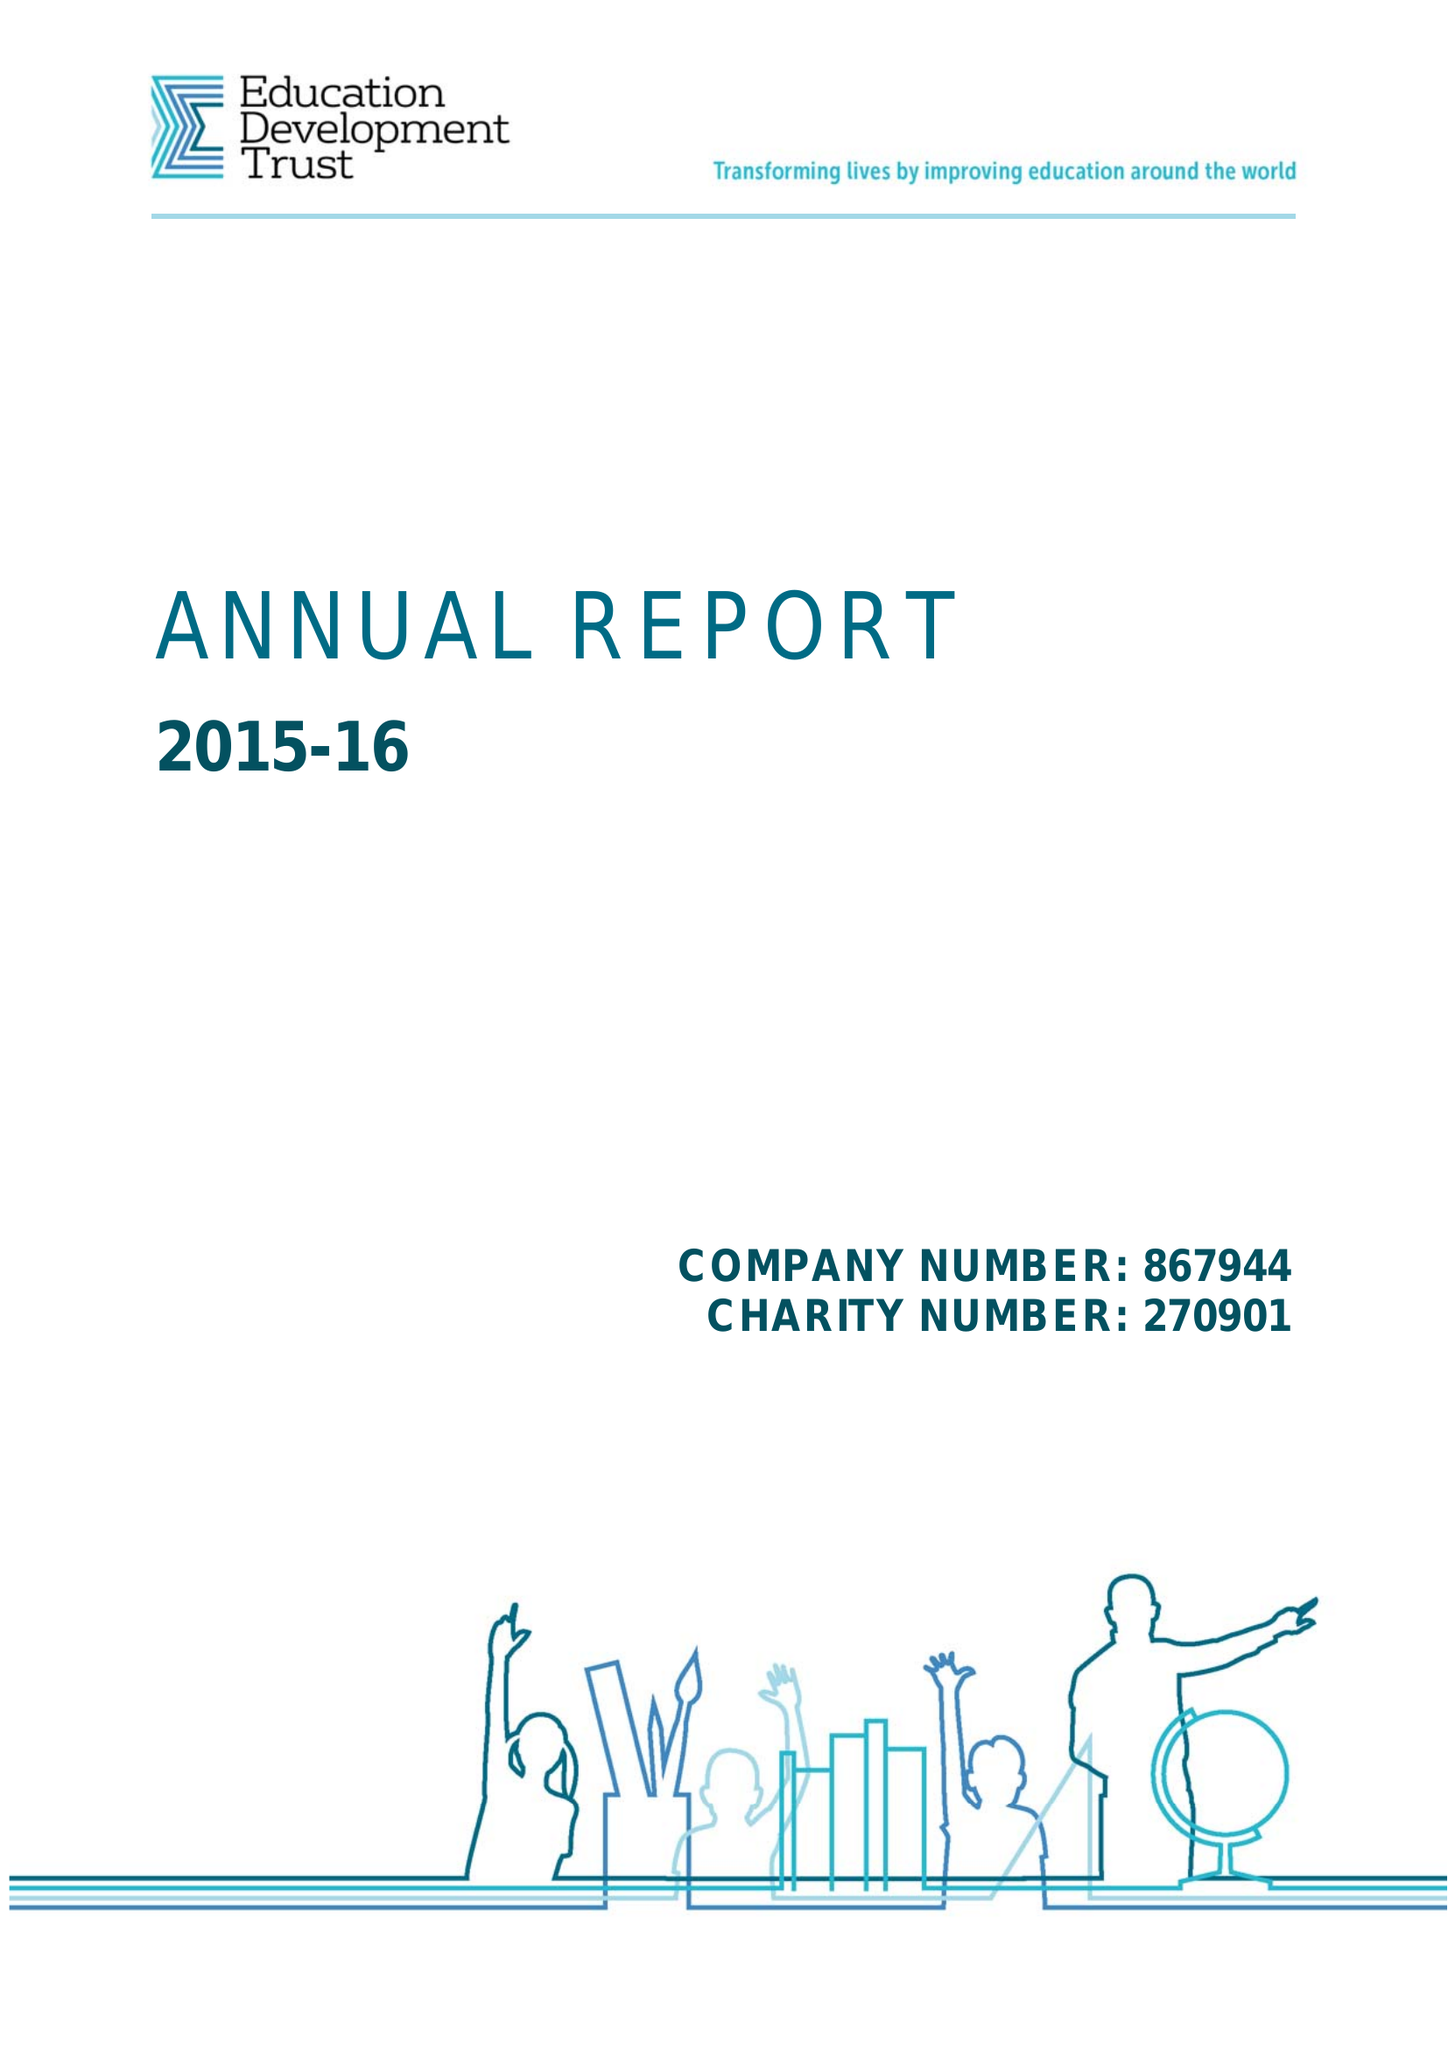What is the value for the address__postcode?
Answer the question using a single word or phrase. RG1 4RU 